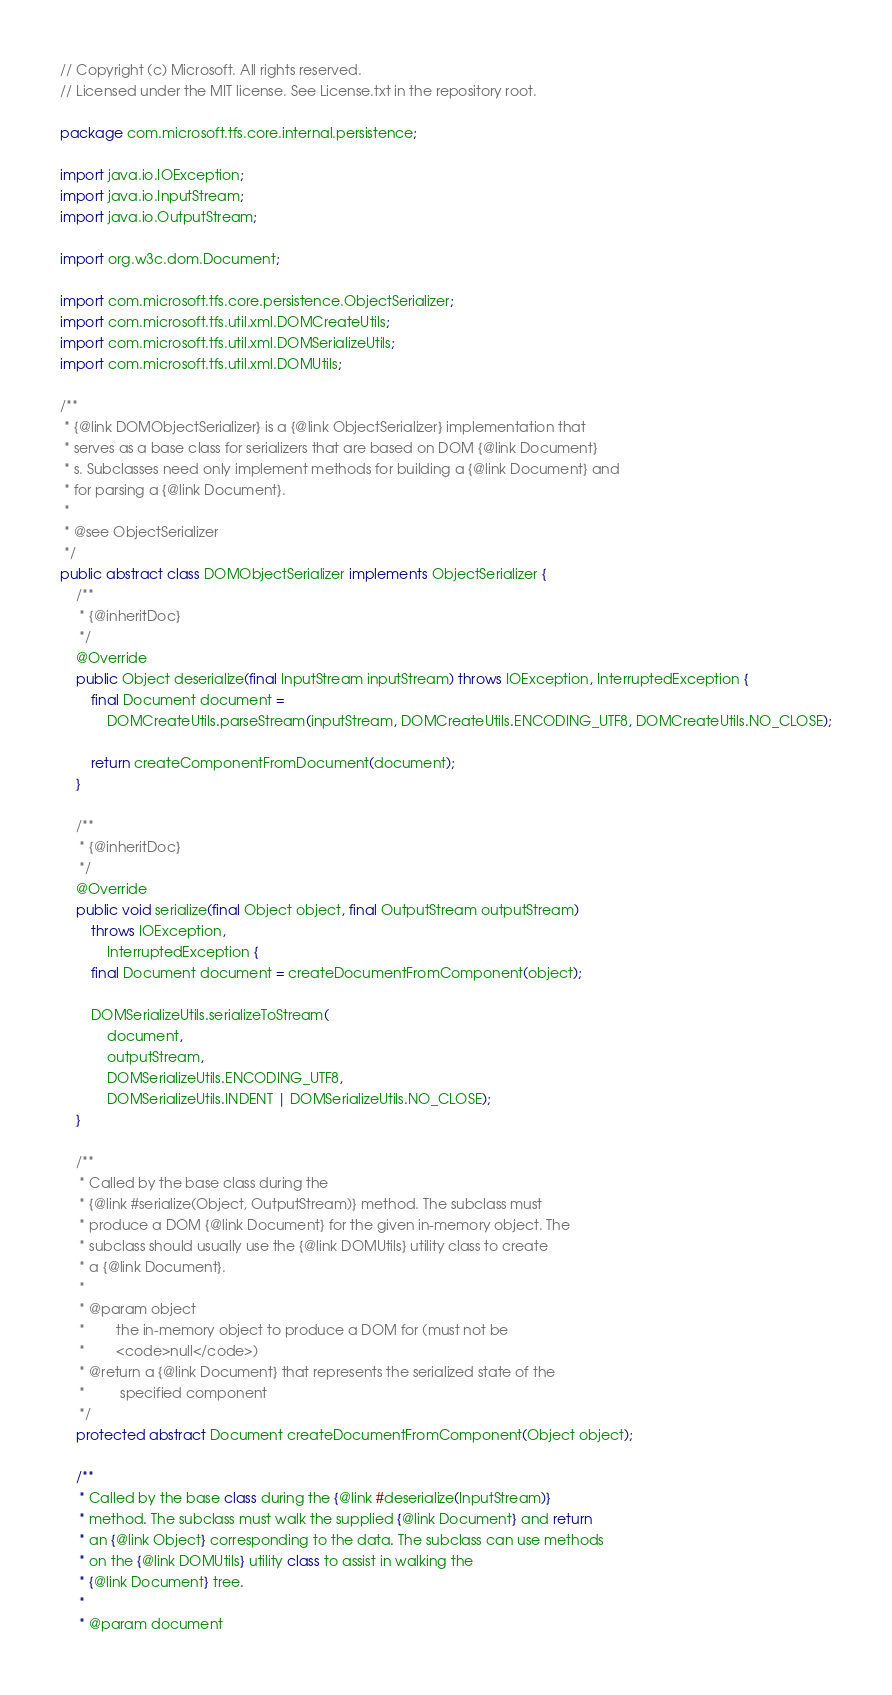Convert code to text. <code><loc_0><loc_0><loc_500><loc_500><_Java_>// Copyright (c) Microsoft. All rights reserved.
// Licensed under the MIT license. See License.txt in the repository root.

package com.microsoft.tfs.core.internal.persistence;

import java.io.IOException;
import java.io.InputStream;
import java.io.OutputStream;

import org.w3c.dom.Document;

import com.microsoft.tfs.core.persistence.ObjectSerializer;
import com.microsoft.tfs.util.xml.DOMCreateUtils;
import com.microsoft.tfs.util.xml.DOMSerializeUtils;
import com.microsoft.tfs.util.xml.DOMUtils;

/**
 * {@link DOMObjectSerializer} is a {@link ObjectSerializer} implementation that
 * serves as a base class for serializers that are based on DOM {@link Document}
 * s. Subclasses need only implement methods for building a {@link Document} and
 * for parsing a {@link Document}.
 *
 * @see ObjectSerializer
 */
public abstract class DOMObjectSerializer implements ObjectSerializer {
    /**
     * {@inheritDoc}
     */
    @Override
    public Object deserialize(final InputStream inputStream) throws IOException, InterruptedException {
        final Document document =
            DOMCreateUtils.parseStream(inputStream, DOMCreateUtils.ENCODING_UTF8, DOMCreateUtils.NO_CLOSE);

        return createComponentFromDocument(document);
    }

    /**
     * {@inheritDoc}
     */
    @Override
    public void serialize(final Object object, final OutputStream outputStream)
        throws IOException,
            InterruptedException {
        final Document document = createDocumentFromComponent(object);

        DOMSerializeUtils.serializeToStream(
            document,
            outputStream,
            DOMSerializeUtils.ENCODING_UTF8,
            DOMSerializeUtils.INDENT | DOMSerializeUtils.NO_CLOSE);
    }

    /**
     * Called by the base class during the
     * {@link #serialize(Object, OutputStream)} method. The subclass must
     * produce a DOM {@link Document} for the given in-memory object. The
     * subclass should usually use the {@link DOMUtils} utility class to create
     * a {@link Document}.
     *
     * @param object
     *        the in-memory object to produce a DOM for (must not be
     *        <code>null</code>)
     * @return a {@link Document} that represents the serialized state of the
     *         specified component
     */
    protected abstract Document createDocumentFromComponent(Object object);

    /**
     * Called by the base class during the {@link #deserialize(InputStream)}
     * method. The subclass must walk the supplied {@link Document} and return
     * an {@link Object} corresponding to the data. The subclass can use methods
     * on the {@link DOMUtils} utility class to assist in walking the
     * {@link Document} tree.
     *
     * @param document</code> 